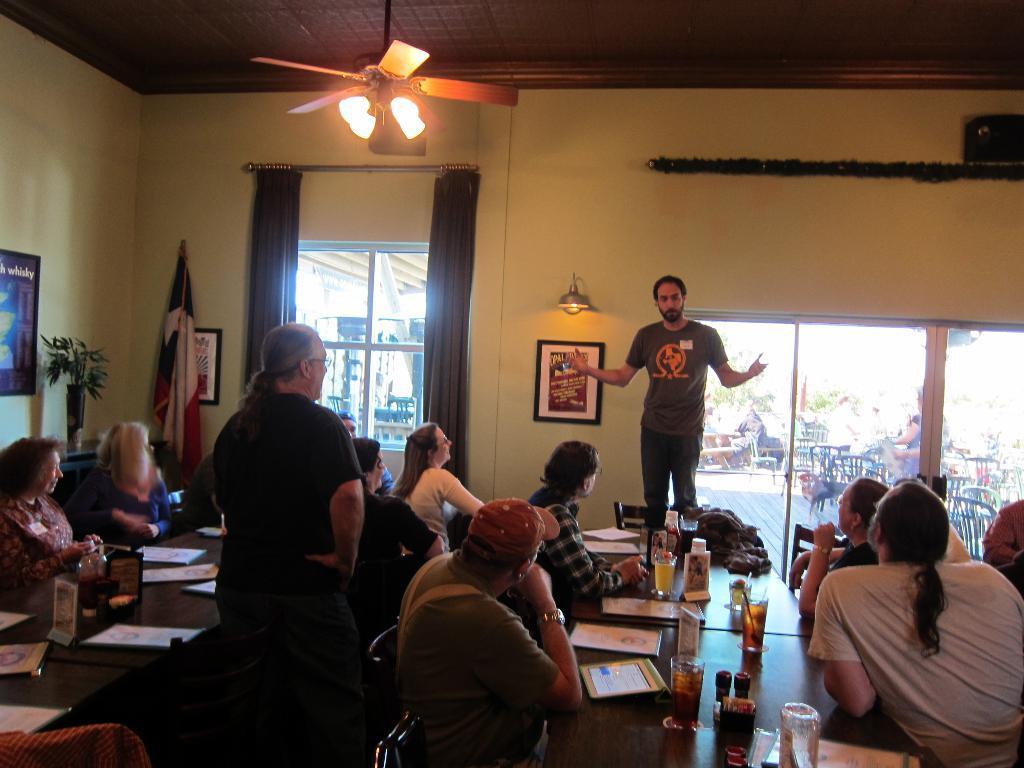How would you summarize this image in a sentence or two? I can see in this image a group of people among them few are sitting on a chair in front of a table and few are standing. On the table we have few glasses and other objects on it. In the background I can see curtain, a window and a chandelier with fan and other objects. 